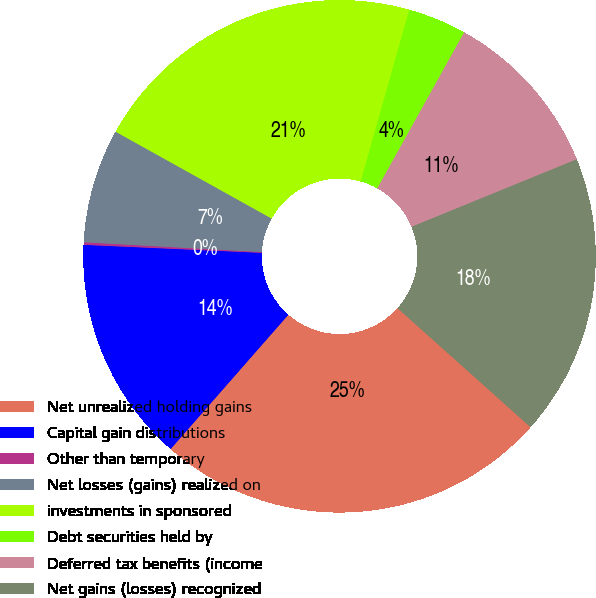Convert chart to OTSL. <chart><loc_0><loc_0><loc_500><loc_500><pie_chart><fcel>Net unrealized holding gains<fcel>Capital gain distributions<fcel>Other than temporary<fcel>Net losses (gains) realized on<fcel>investments in sponsored<fcel>Debt securities held by<fcel>Deferred tax benefits (income<fcel>Net gains (losses) recognized<nl><fcel>24.84%<fcel>14.26%<fcel>0.16%<fcel>7.21%<fcel>21.31%<fcel>3.69%<fcel>10.74%<fcel>17.79%<nl></chart> 